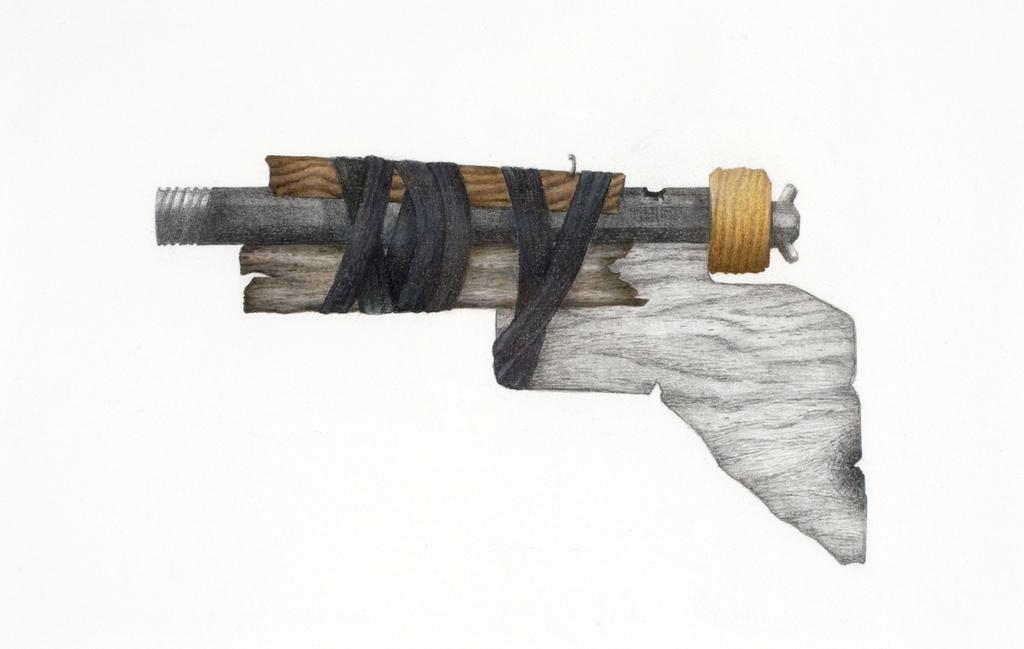What object in the image resembles a gun? There is an object in the image that resembles a gun. What is the color of the background in the image? The background of the image is white. How many giants are visible in the image? There are no giants present in the image. What type of cattle can be seen grazing in the image? There is no cattle present in the image. 